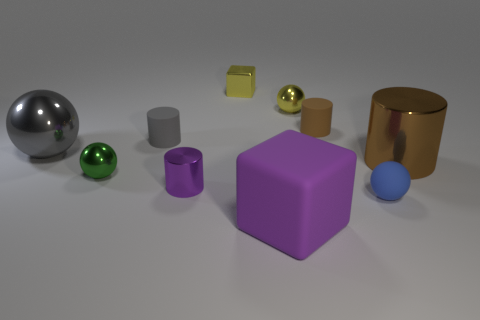There is a tiny thing that is the same color as the rubber cube; what is its material?
Give a very brief answer. Metal. The big gray shiny object has what shape?
Make the answer very short. Sphere. Is the number of blue matte objects behind the small purple cylinder greater than the number of blue spheres?
Your answer should be very brief. No. There is a metal thing that is in front of the tiny green shiny sphere; what shape is it?
Offer a terse response. Cylinder. What number of other things are there of the same shape as the small gray thing?
Provide a short and direct response. 3. Is the material of the large object that is in front of the small metal cylinder the same as the tiny purple thing?
Offer a terse response. No. Are there an equal number of tiny brown cylinders that are in front of the blue rubber sphere and tiny metal cylinders on the left side of the green sphere?
Make the answer very short. Yes. There is a brown object that is behind the large brown shiny object; how big is it?
Provide a short and direct response. Small. Are there any small yellow balls made of the same material as the tiny brown cylinder?
Keep it short and to the point. No. Do the large metal object that is in front of the big gray metal object and the small metal cube have the same color?
Your answer should be compact. No. 